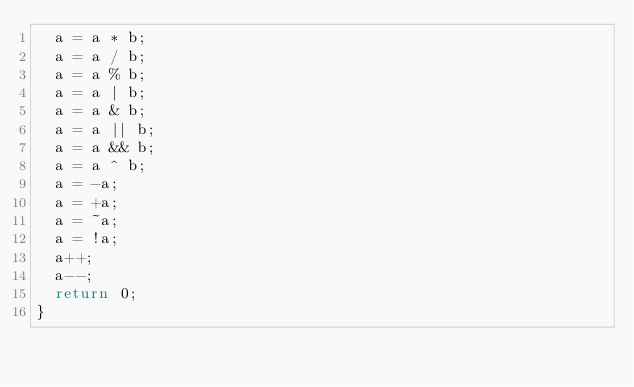<code> <loc_0><loc_0><loc_500><loc_500><_C_>  a = a * b;
  a = a / b;
  a = a % b;
  a = a | b;
  a = a & b;
  a = a || b;
  a = a && b;
  a = a ^ b;
  a = -a;
  a = +a;
  a = ~a;
  a = !a;
  a++;
  a--;
  return 0;
}
</code> 